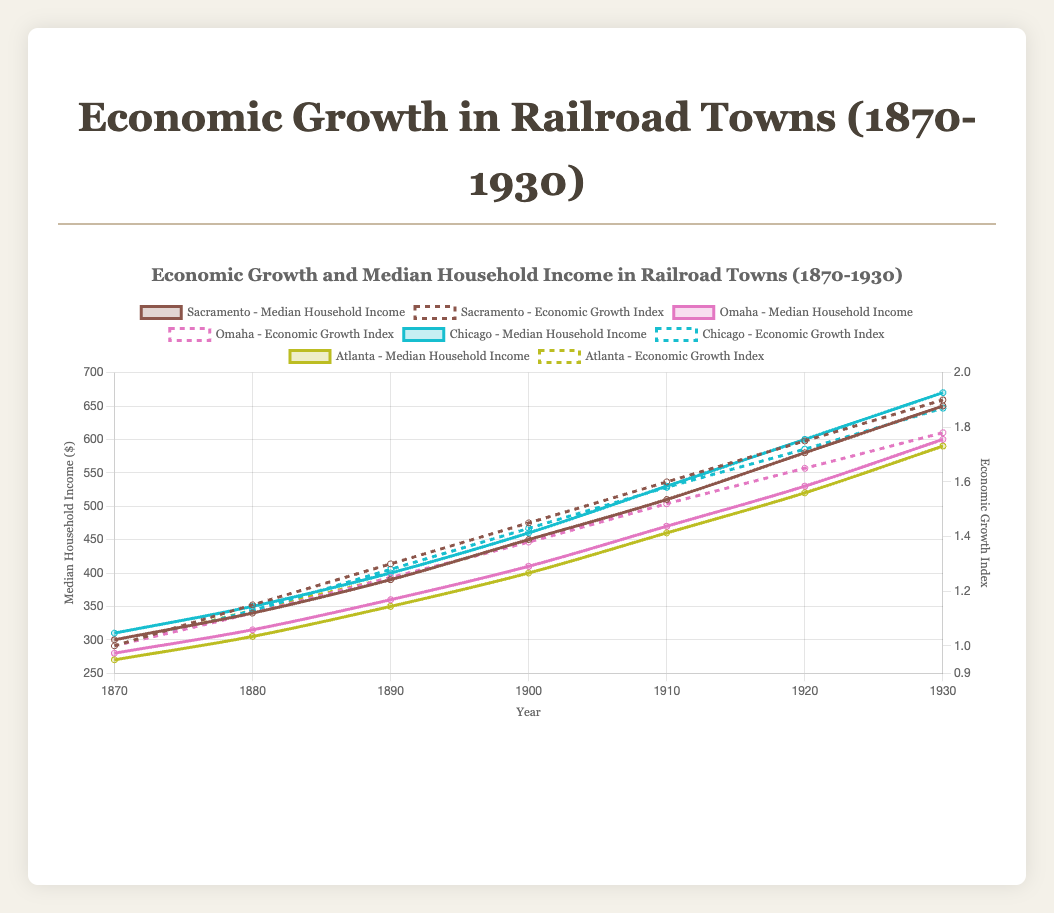How did Sacramento's median household income change from 1870 to 1930? Sacramento's median household income in 1870 was $300 and increased to $650 in 1930. The change is calculated as $650 - $300, which equals $350.
Answer: $350 Which town had the highest median household income in 1930, and what was the value? Looking at the median household income for all towns in 1930, Chicago had the highest with an income of $670.
Answer: Chicago, $670 From 1870 to 1930, which town showed more consistent economic growth based on the Economic Growth Index line? Comparing the lines representing the Economic Growth Index, Sacramento's line steadily increases, showing more consistent growth compared to the other towns.
Answer: Sacramento What was the average economic growth index for Omaha in the years 1900, 1910, and 1920? Omaha's economic growth indices for the years 1900, 1910, and 1920 are 1.38, 1.52, and 1.65, respectively. The average is calculated as (1.38 + 1.52 + 1.65) / 3 = 4.55 / 3 = 1.517.
Answer: 1.52 Did any town's median household income surpass $500 by the year 1910? By analyzing the median household income values across the towns in 1910, none of the towns surpassed $500. Sacramento reached $510 in 1910, but this was after 1910 and not by it.
Answer: No How does the economic growth of Atlanta compare to Chicago in 1930? In 1930, Atlanta had an Economic Growth Index of 1.78, while Chicago had 1.87. Hence, Chicago's economic growth was higher.
Answer: Chicago's is higher Which town experienced the smallest increase in median household income between 1900 and 1910? The increases by town are: Sacramento ($450 to $510 = $60), Omaha ($410 to $470 = $60), Chicago ($460 to $530 = $70), Atlanta ($400 to $460 = $60). All towns except Chicago showed an increase of $60, so the smallest is in Sacramento, Omaha, and Atlanta.
Answer: Sacramento, Omaha, and Atlanta What was the total median household income for all towns combined in 1880? The median household incomes for Sacramento, Omaha, Chicago, and Atlanta in 1880 are $340, $315, $350, and $305 respectively. The total is $340 + $315 + $350 + $305 = $1310.
Answer: $1310 Did any town's Economic Growth Index reach or exceed 1.90 by 1930? By examining the Economic Growth Index for each town in 1930, Sacramento reached 1.90, while the others (Omaha, Chicago, Atlanta) did not.
Answer: Sacramento During which decade did Omaha see the highest increase in median household income? By calculating increases between decades: 1870-1880 ($280 to $315 = $35), 1880-1890 ($315 to $360 = $45), 1890-1900 ($360 to $410 = $50), 1900-1910 ($410 to $470 = $60), 1910-1920 ($470 to $530 = $60), 1920-1930 ($530 to $600 = $70). The highest increase was in 1920-1930.
Answer: 1920-1930 